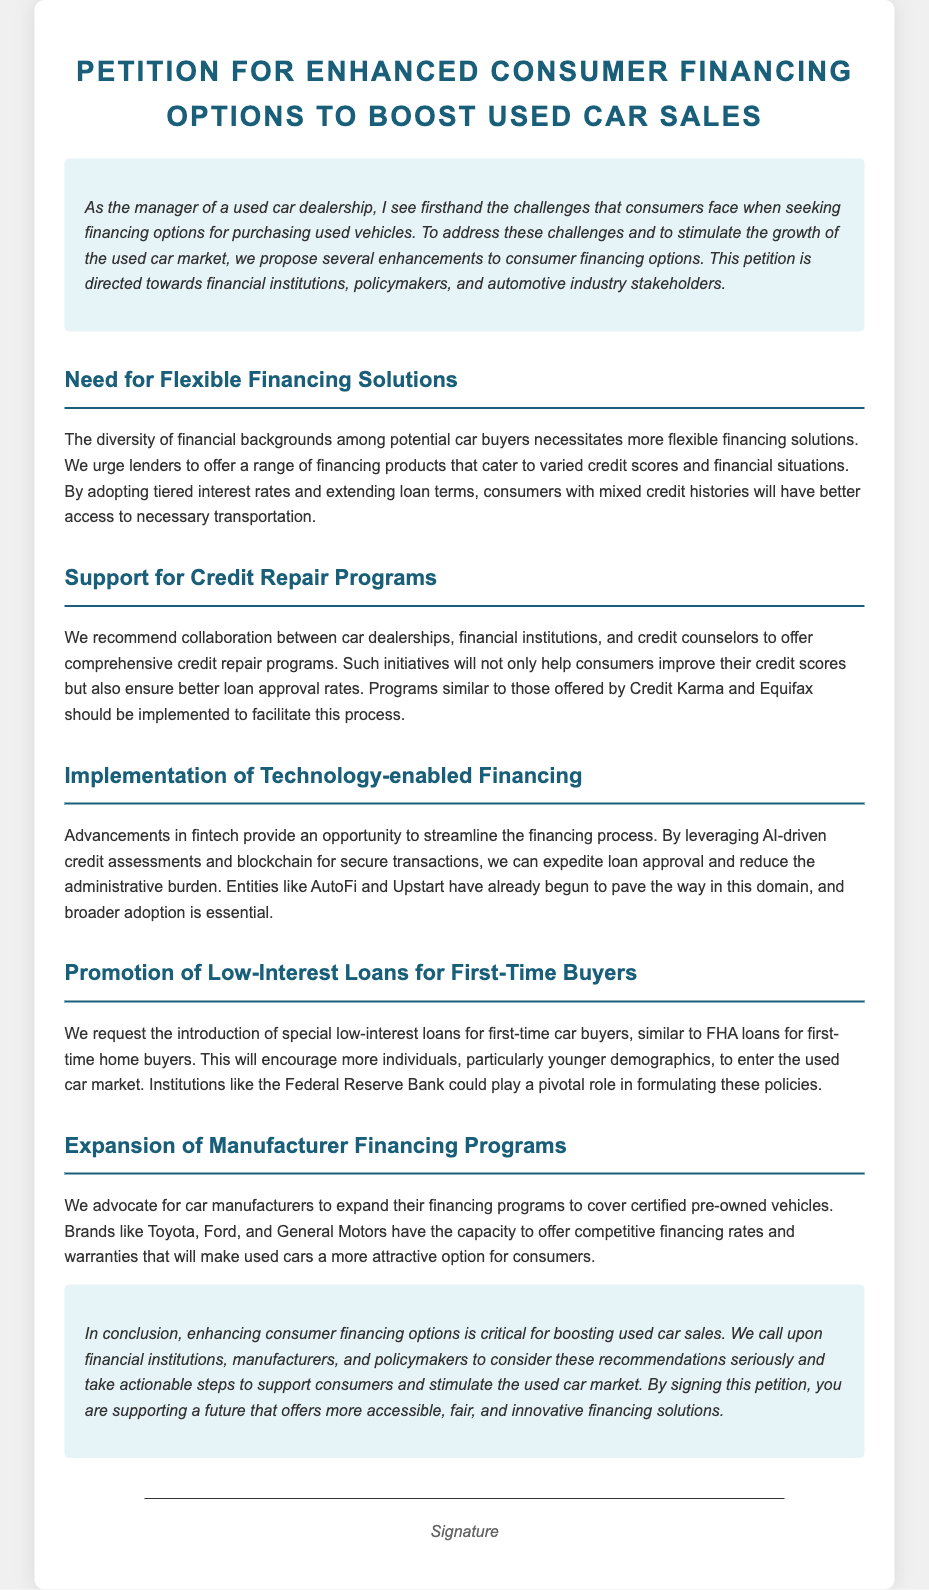What is the primary purpose of the petition? The primary purpose of the petition is to propose enhancements to consumer financing options to stimulate the growth of the used car market.
Answer: To propose enhancements to consumer financing options What type of programs are recommended for credit repair? The document recommends collaboration to offer comprehensive credit repair programs, similar to those by Credit Karma and Equifax.
Answer: Comprehensive credit repair programs Which technologies are suggested for streamlining financing? The petition suggests leveraging AI-driven credit assessments and blockchain for secure transactions to streamline the financing process.
Answer: AI-driven credit assessments and blockchain What loan type is requested for first-time car buyers? The document requests the introduction of special low-interest loans for first-time car buyers.
Answer: Special low-interest loans Who is the target audience of this petition? The target audience of this petition includes financial institutions, policymakers, and automotive industry stakeholders.
Answer: Financial institutions, policymakers, automotive industry stakeholders Why is it important to enhance financing options? Enhancing financing options is critical for boosting used car sales, as stated in the conclusion of the document.
Answer: To boost used car sales How should manufacturers expand their financing programs? Manufacturers are encouraged to expand their financing programs to cover certified pre-owned vehicles.
Answer: Cover certified pre-owned vehicles What organizations might benefit from shared credit repair initiatives? Car dealerships, financial institutions, and credit counselors are suggested to benefit from collaborative credit repair initiatives.
Answer: Car dealerships, financial institutions, credit counselors 